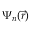<formula> <loc_0><loc_0><loc_500><loc_500>\Psi _ { n } ( \vec { r } )</formula> 